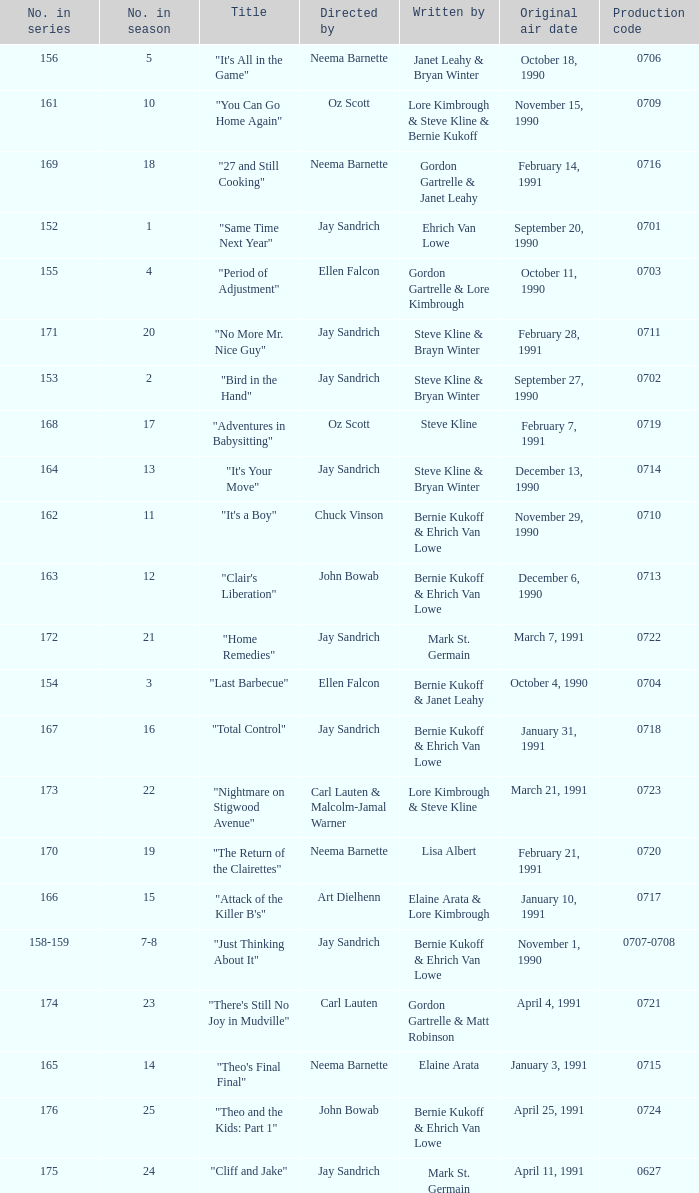Who directed the episode entitled "it's your move"? Jay Sandrich. 